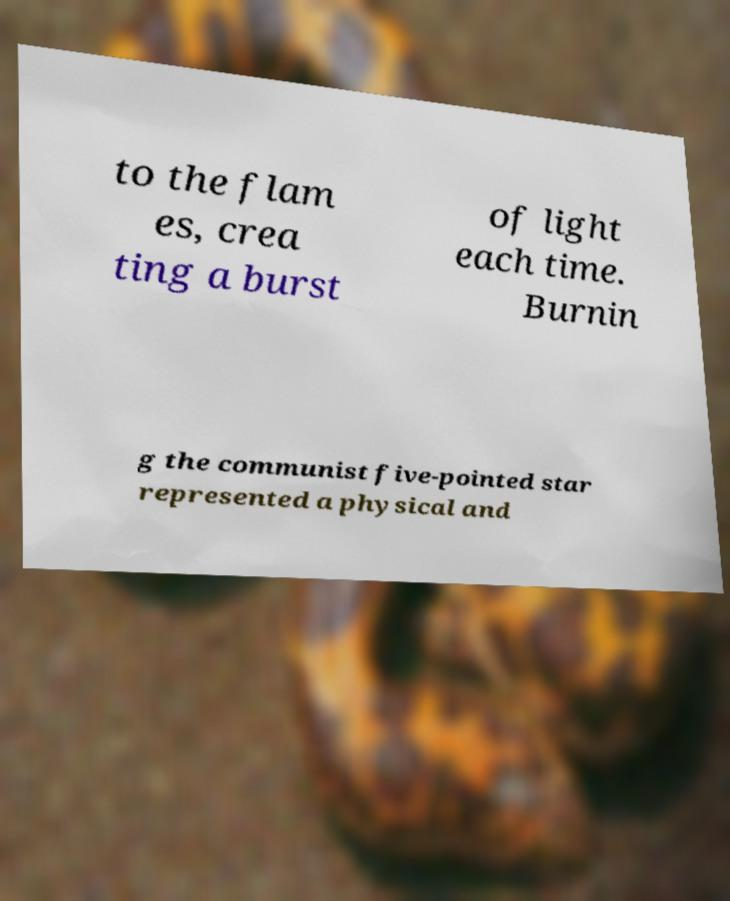For documentation purposes, I need the text within this image transcribed. Could you provide that? to the flam es, crea ting a burst of light each time. Burnin g the communist five-pointed star represented a physical and 